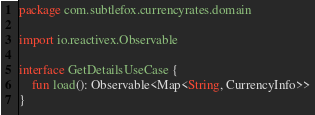Convert code to text. <code><loc_0><loc_0><loc_500><loc_500><_Kotlin_>package com.subtlefox.currencyrates.domain

import io.reactivex.Observable

interface GetDetailsUseCase {
    fun load(): Observable<Map<String, CurrencyInfo>>
}</code> 